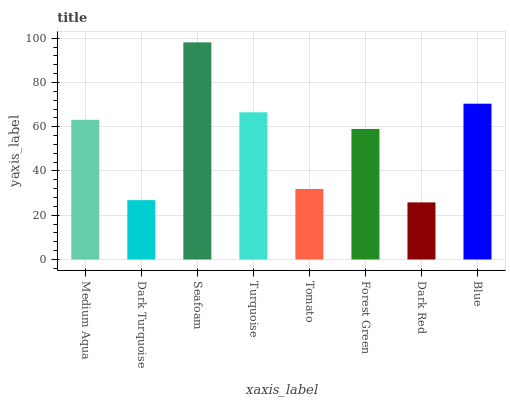Is Dark Red the minimum?
Answer yes or no. Yes. Is Seafoam the maximum?
Answer yes or no. Yes. Is Dark Turquoise the minimum?
Answer yes or no. No. Is Dark Turquoise the maximum?
Answer yes or no. No. Is Medium Aqua greater than Dark Turquoise?
Answer yes or no. Yes. Is Dark Turquoise less than Medium Aqua?
Answer yes or no. Yes. Is Dark Turquoise greater than Medium Aqua?
Answer yes or no. No. Is Medium Aqua less than Dark Turquoise?
Answer yes or no. No. Is Medium Aqua the high median?
Answer yes or no. Yes. Is Forest Green the low median?
Answer yes or no. Yes. Is Turquoise the high median?
Answer yes or no. No. Is Dark Turquoise the low median?
Answer yes or no. No. 